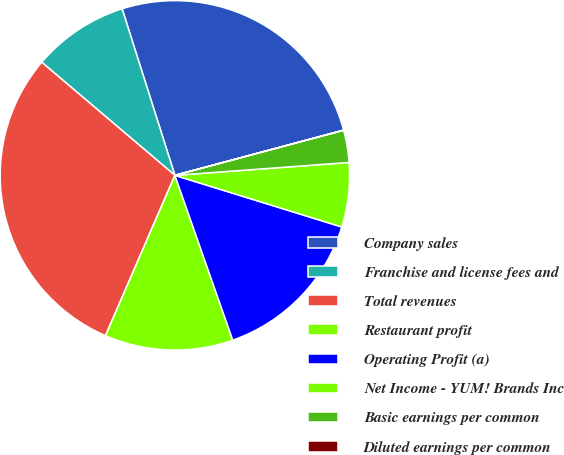Convert chart. <chart><loc_0><loc_0><loc_500><loc_500><pie_chart><fcel>Company sales<fcel>Franchise and license fees and<fcel>Total revenues<fcel>Restaurant profit<fcel>Operating Profit (a)<fcel>Net Income - YUM! Brands Inc<fcel>Basic earnings per common<fcel>Diluted earnings per common<nl><fcel>25.72%<fcel>8.91%<fcel>29.7%<fcel>11.88%<fcel>14.85%<fcel>5.95%<fcel>2.98%<fcel>0.01%<nl></chart> 